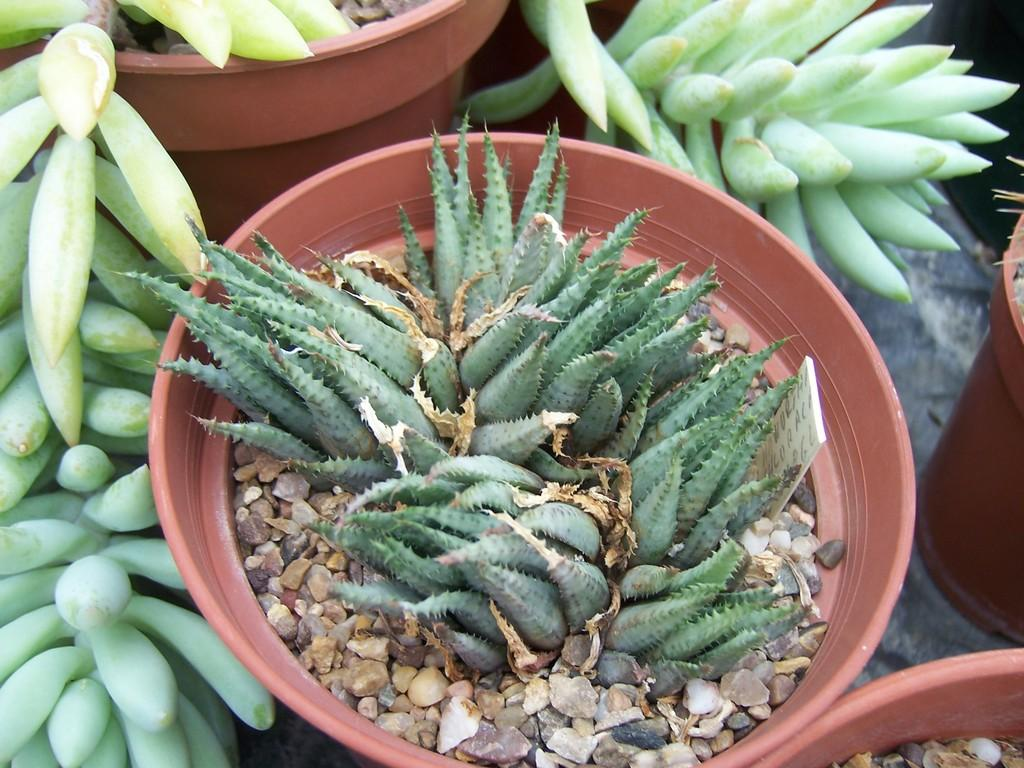What is in the flower pot in the image? There are aloe Vera plants in the flower pot. What color are the aloe Vera plants? The aloe Vera plants are green. Are there any other green objects in the image? Yes, there are other green objects in the image. What type of rhythm can be heard coming from the brass instruments in the image? There are no brass instruments or any rhythm present in the image; it features a flower pot with aloe Vera plants and other green objects. 